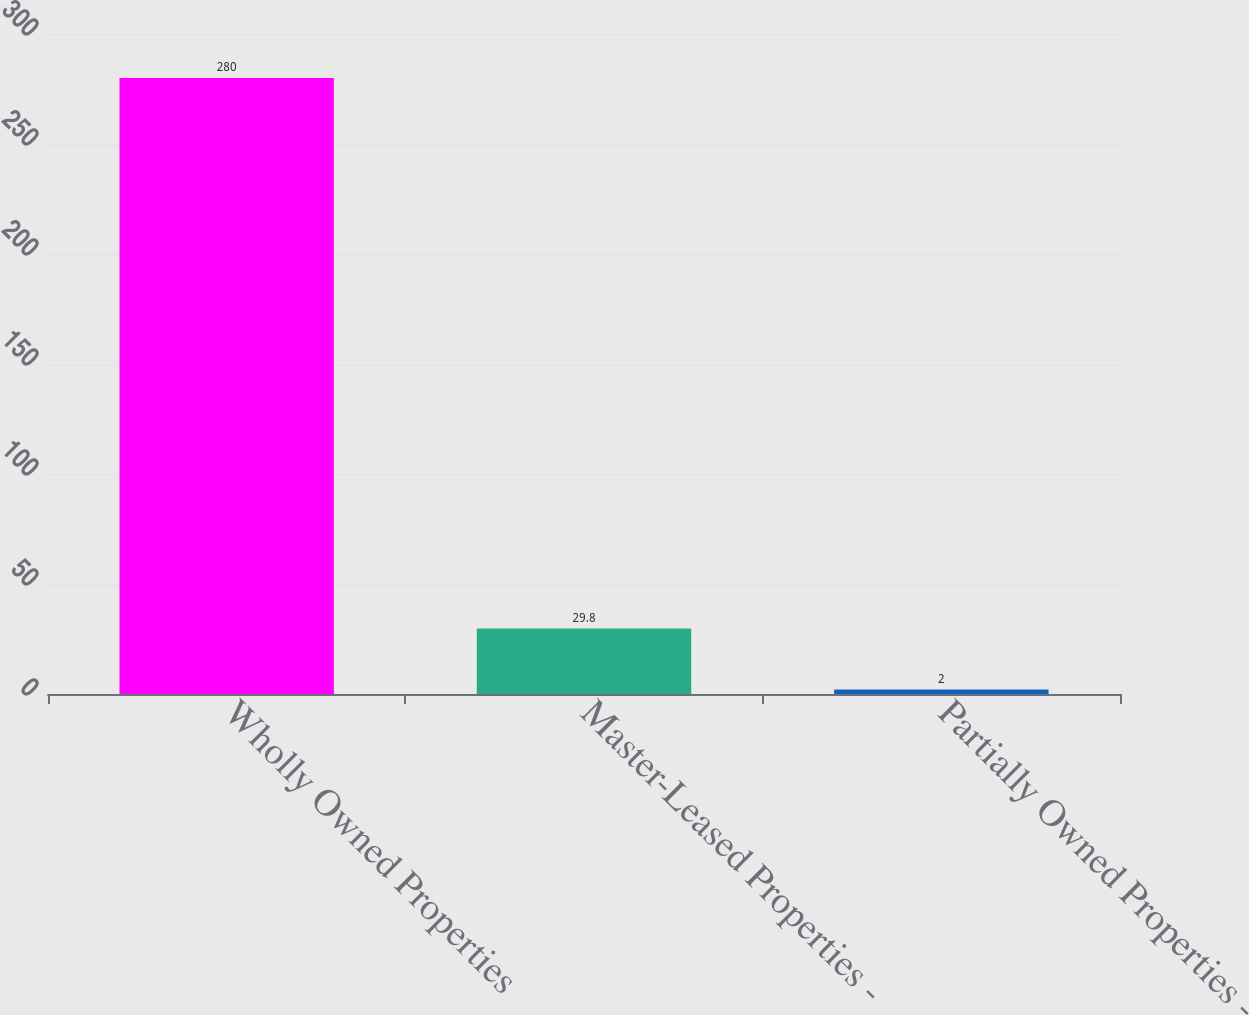Convert chart to OTSL. <chart><loc_0><loc_0><loc_500><loc_500><bar_chart><fcel>Wholly Owned Properties<fcel>Master-Leased Properties -<fcel>Partially Owned Properties -<nl><fcel>280<fcel>29.8<fcel>2<nl></chart> 